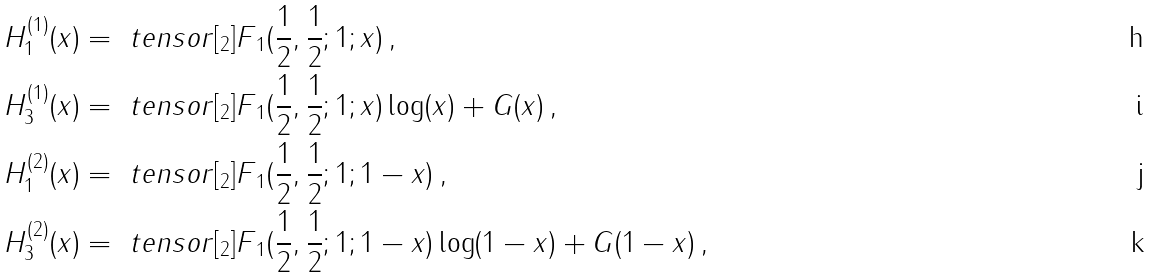<formula> <loc_0><loc_0><loc_500><loc_500>H _ { 1 } ^ { ( 1 ) } ( x ) & = \ t e n s o r [ _ { 2 } ] { F } { _ { 1 } } ( \frac { 1 } { 2 } , \frac { 1 } { 2 } ; 1 ; x ) \, , \\ H _ { 3 } ^ { ( 1 ) } ( x ) & = \ t e n s o r [ _ { 2 } ] { F } { _ { 1 } } ( \frac { 1 } { 2 } , \frac { 1 } { 2 } ; 1 ; x ) \log ( x ) + G ( x ) \, , \\ H _ { 1 } ^ { ( 2 ) } ( x ) & = \ t e n s o r [ _ { 2 } ] { F } { _ { 1 } } ( \frac { 1 } { 2 } , \frac { 1 } { 2 } ; 1 ; 1 - x ) \, , \\ H _ { 3 } ^ { ( 2 ) } ( x ) & = \ t e n s o r [ _ { 2 } ] { F } { _ { 1 } } ( \frac { 1 } { 2 } , \frac { 1 } { 2 } ; 1 ; 1 - x ) \log ( 1 - x ) + G ( 1 - x ) \, ,</formula> 